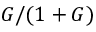Convert formula to latex. <formula><loc_0><loc_0><loc_500><loc_500>G / ( 1 + G )</formula> 